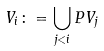Convert formula to latex. <formula><loc_0><loc_0><loc_500><loc_500>V _ { i } \colon = \bigcup _ { j < i } P V _ { j }</formula> 